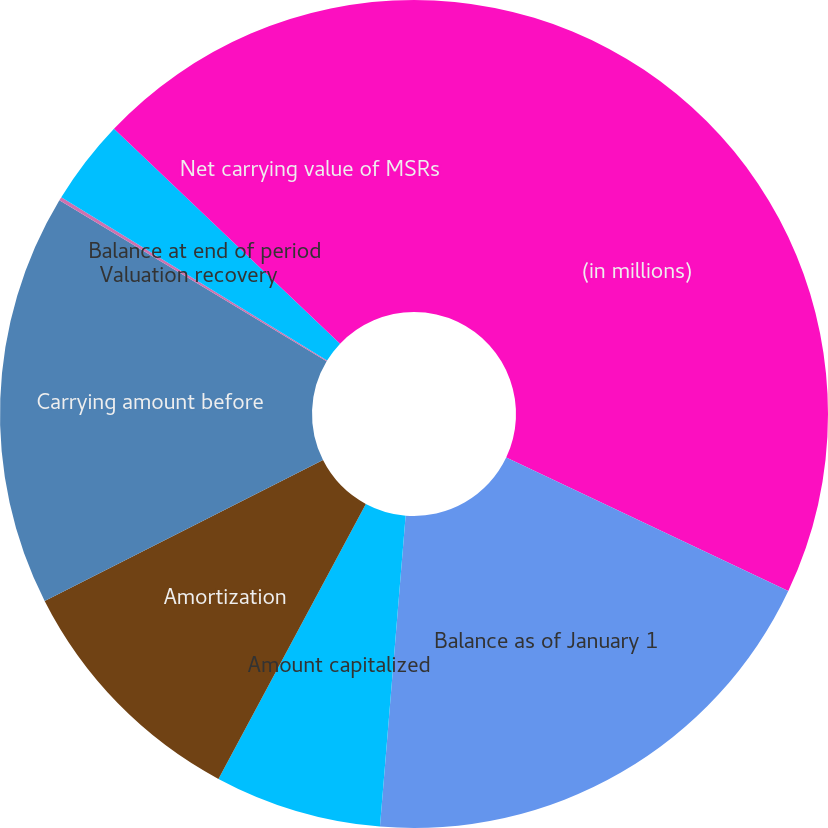<chart> <loc_0><loc_0><loc_500><loc_500><pie_chart><fcel>(in millions)<fcel>Balance as of January 1<fcel>Amount capitalized<fcel>Amortization<fcel>Carrying amount before<fcel>Valuation recovery<fcel>Balance at end of period<fcel>Net carrying value of MSRs<nl><fcel>32.03%<fcel>19.28%<fcel>6.52%<fcel>9.71%<fcel>16.09%<fcel>0.14%<fcel>3.33%<fcel>12.9%<nl></chart> 